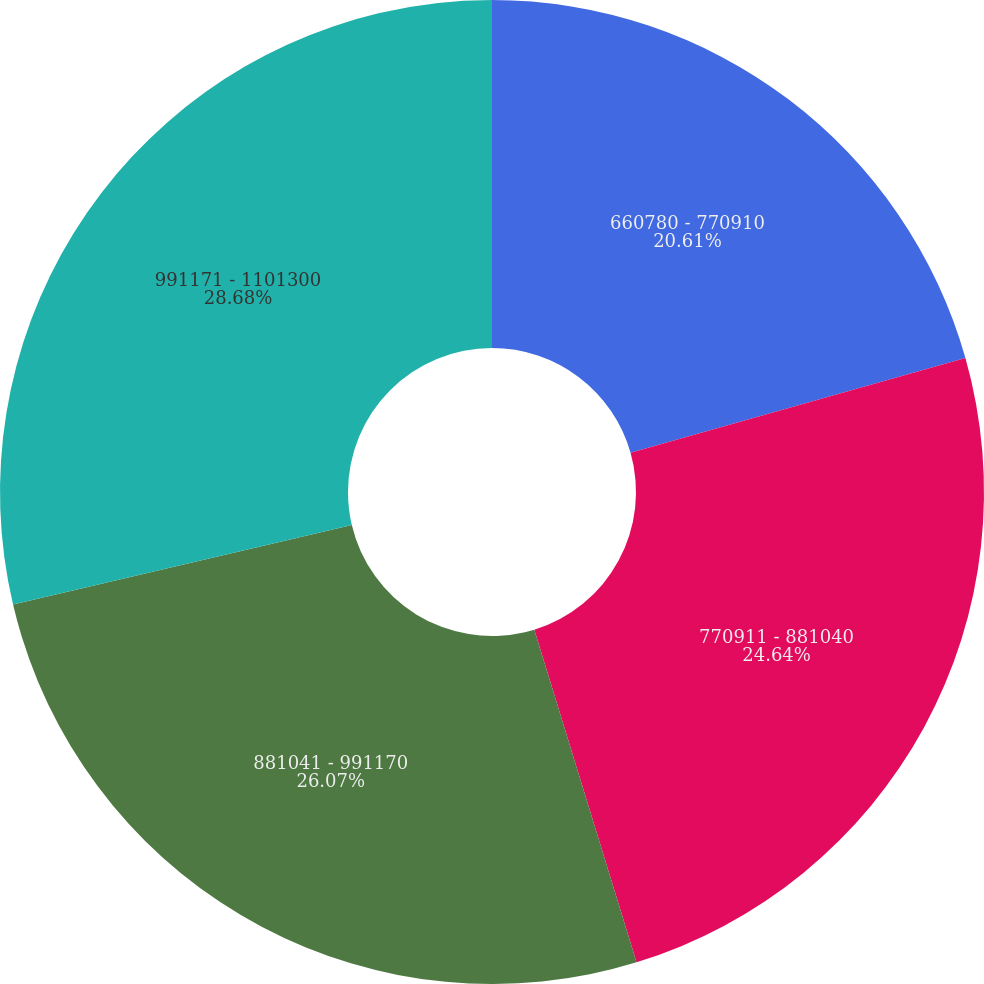<chart> <loc_0><loc_0><loc_500><loc_500><pie_chart><fcel>660780 - 770910<fcel>770911 - 881040<fcel>881041 - 991170<fcel>991171 - 1101300<nl><fcel>20.61%<fcel>24.64%<fcel>26.07%<fcel>28.67%<nl></chart> 